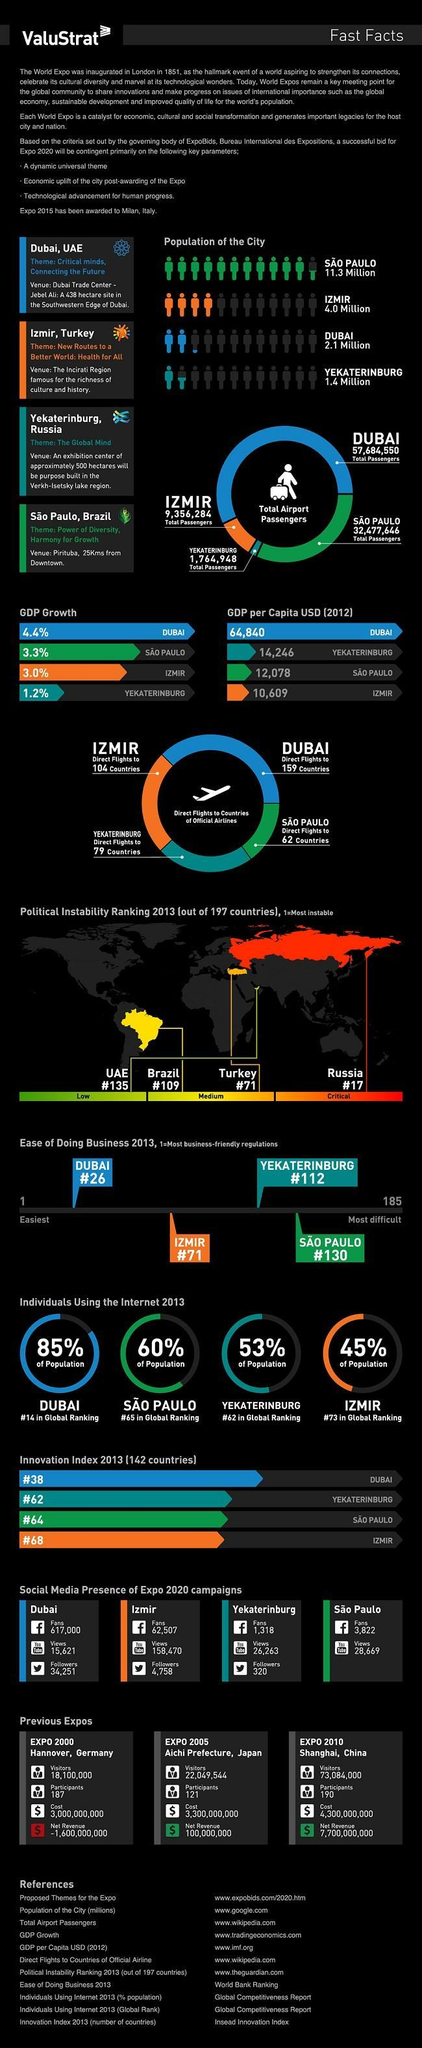Dubai has direct flights to how many countries?
Answer the question with a short phrase. 159 What is the GDP per Capita USD in 2012 in Dubai? 66,840 Which country has the lowest total air passengers? Yekaterinburg Which city has the lowest GDP per Capita USD in 2012? IZMIR What is the population of Yekaterinburg City? 1.4 Million What is the population of Sao Paulo City? 11.3 Million What is the population of Dubai City? 2.1 Million Which country has the highest total air passengers? Dubai What is the political instability ranking of Russia in 2013? #17 What is the population of Izmir City? 4.0 Million 